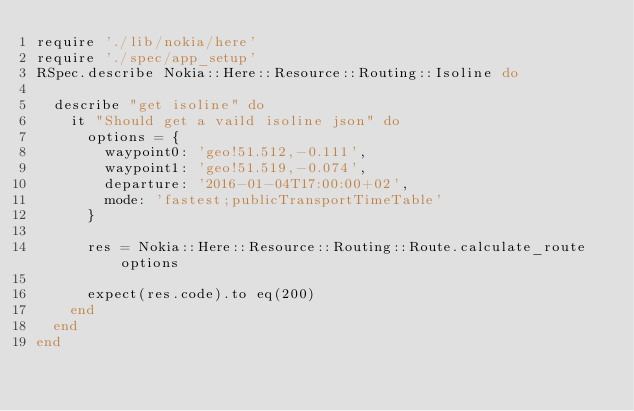<code> <loc_0><loc_0><loc_500><loc_500><_Ruby_>require './lib/nokia/here'
require './spec/app_setup'
RSpec.describe Nokia::Here::Resource::Routing::Isoline do

  describe "get isoline" do
    it "Should get a vaild isoline json" do
      options = {
        waypoint0: 'geo!51.512,-0.111',
        waypoint1: 'geo!51.519,-0.074',
        departure: '2016-01-04T17:00:00+02',
        mode: 'fastest;publicTransportTimeTable'
      }

      res = Nokia::Here::Resource::Routing::Route.calculate_route options

      expect(res.code).to eq(200)
    end
  end
end
</code> 